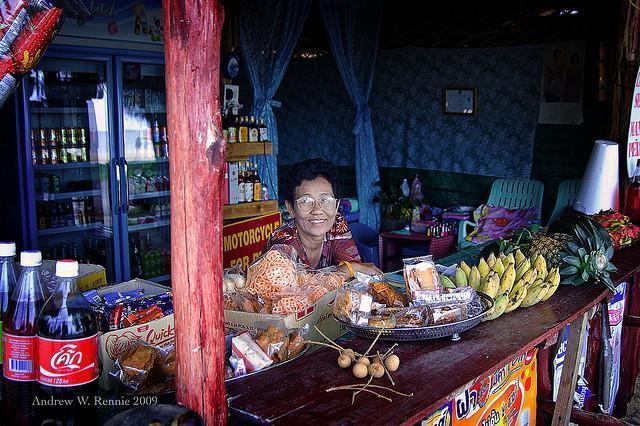How many bottles are visible?
Give a very brief answer. 3. How many refrigerators are there?
Give a very brief answer. 1. 